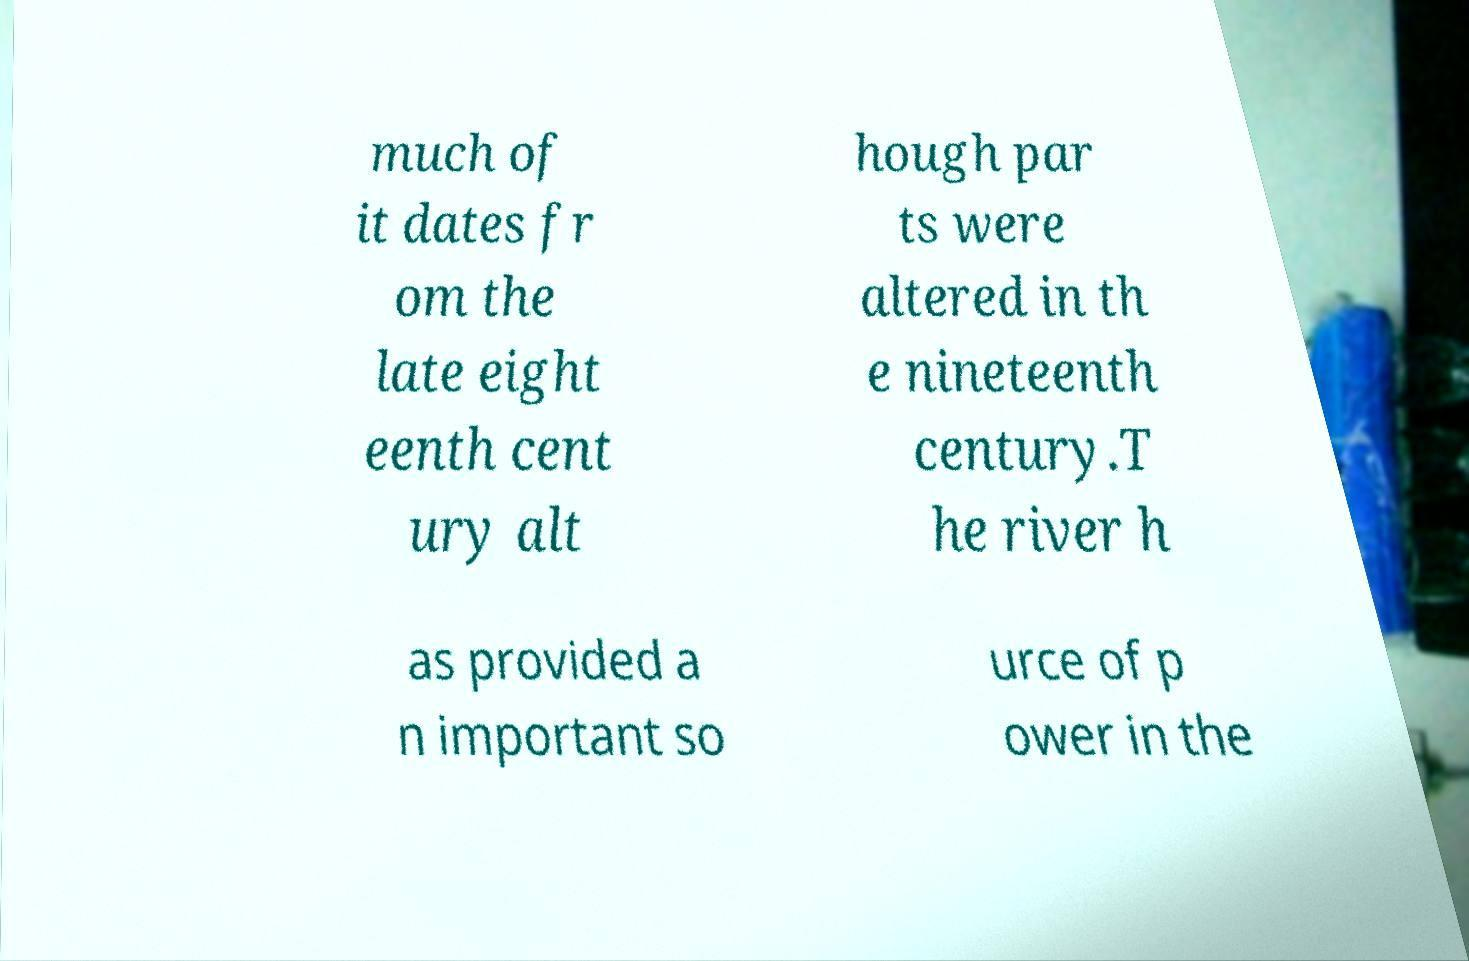I need the written content from this picture converted into text. Can you do that? much of it dates fr om the late eight eenth cent ury alt hough par ts were altered in th e nineteenth century.T he river h as provided a n important so urce of p ower in the 